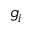Convert formula to latex. <formula><loc_0><loc_0><loc_500><loc_500>g _ { i }</formula> 